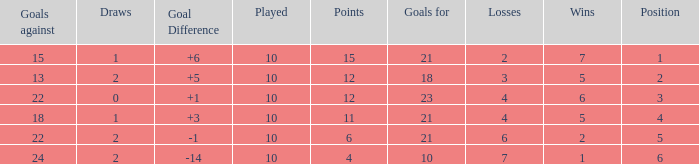Can you tell me the sum of Goals against that has the Goals for larger than 10, and the Position of 3, and the Wins smaller than 6? None. 